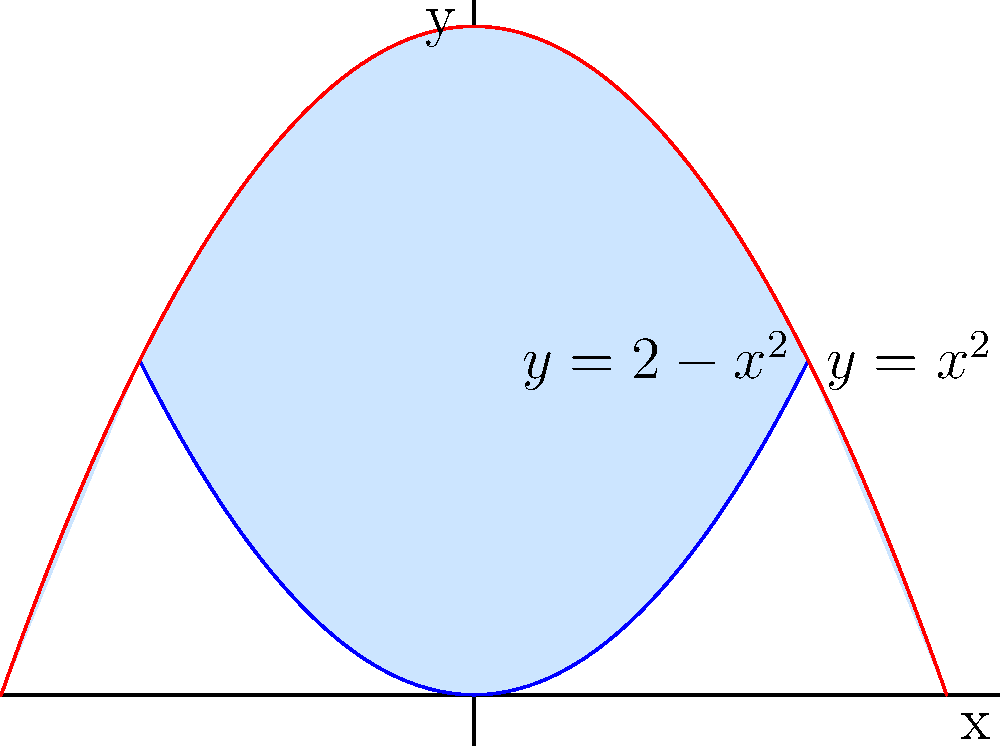As part of your art therapy project, you're designing a visual representation of emotional balance. You decide to use two parabolas to create a shape symbolizing harmony. The parabolas are defined by the equations $y=x^2$ and $y=2-x^2$. Calculate the area of the region bounded by these two parabolas, which will represent the "space of emotional equilibrium" in your artwork. Let's approach this step-by-step:

1) First, we need to find the points of intersection of the two parabolas. We can do this by equating the two equations:

   $x^2 = 2-x^2$

2) Solving this equation:
   $2x^2 = 2$
   $x^2 = 1$
   $x = \pm 1$

3) So the parabolas intersect at $(-1,1)$ and $(1,1)$.

4) The area between the curves can be found by integrating the difference of the upper and lower functions from $-1$ to $1$:

   $A = \int_{-1}^{1} [(2-x^2) - x^2] dx$

5) Simplifying the integrand:
   $A = \int_{-1}^{1} [2 - 2x^2] dx$

6) Integrating:
   $A = [2x - \frac{2x^3}{3}]_{-1}^{1}$

7) Evaluating the definite integral:
   $A = (2 - \frac{2}{3}) - (-2 + \frac{2}{3})$
   $A = \frac{4}{3} + \frac{4}{3} = \frac{8}{3}$

8) Therefore, the area between the parabolas is $\frac{8}{3}$ square units.
Answer: $\frac{8}{3}$ square units 